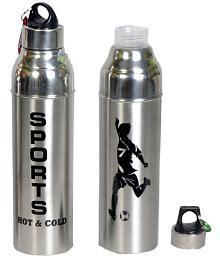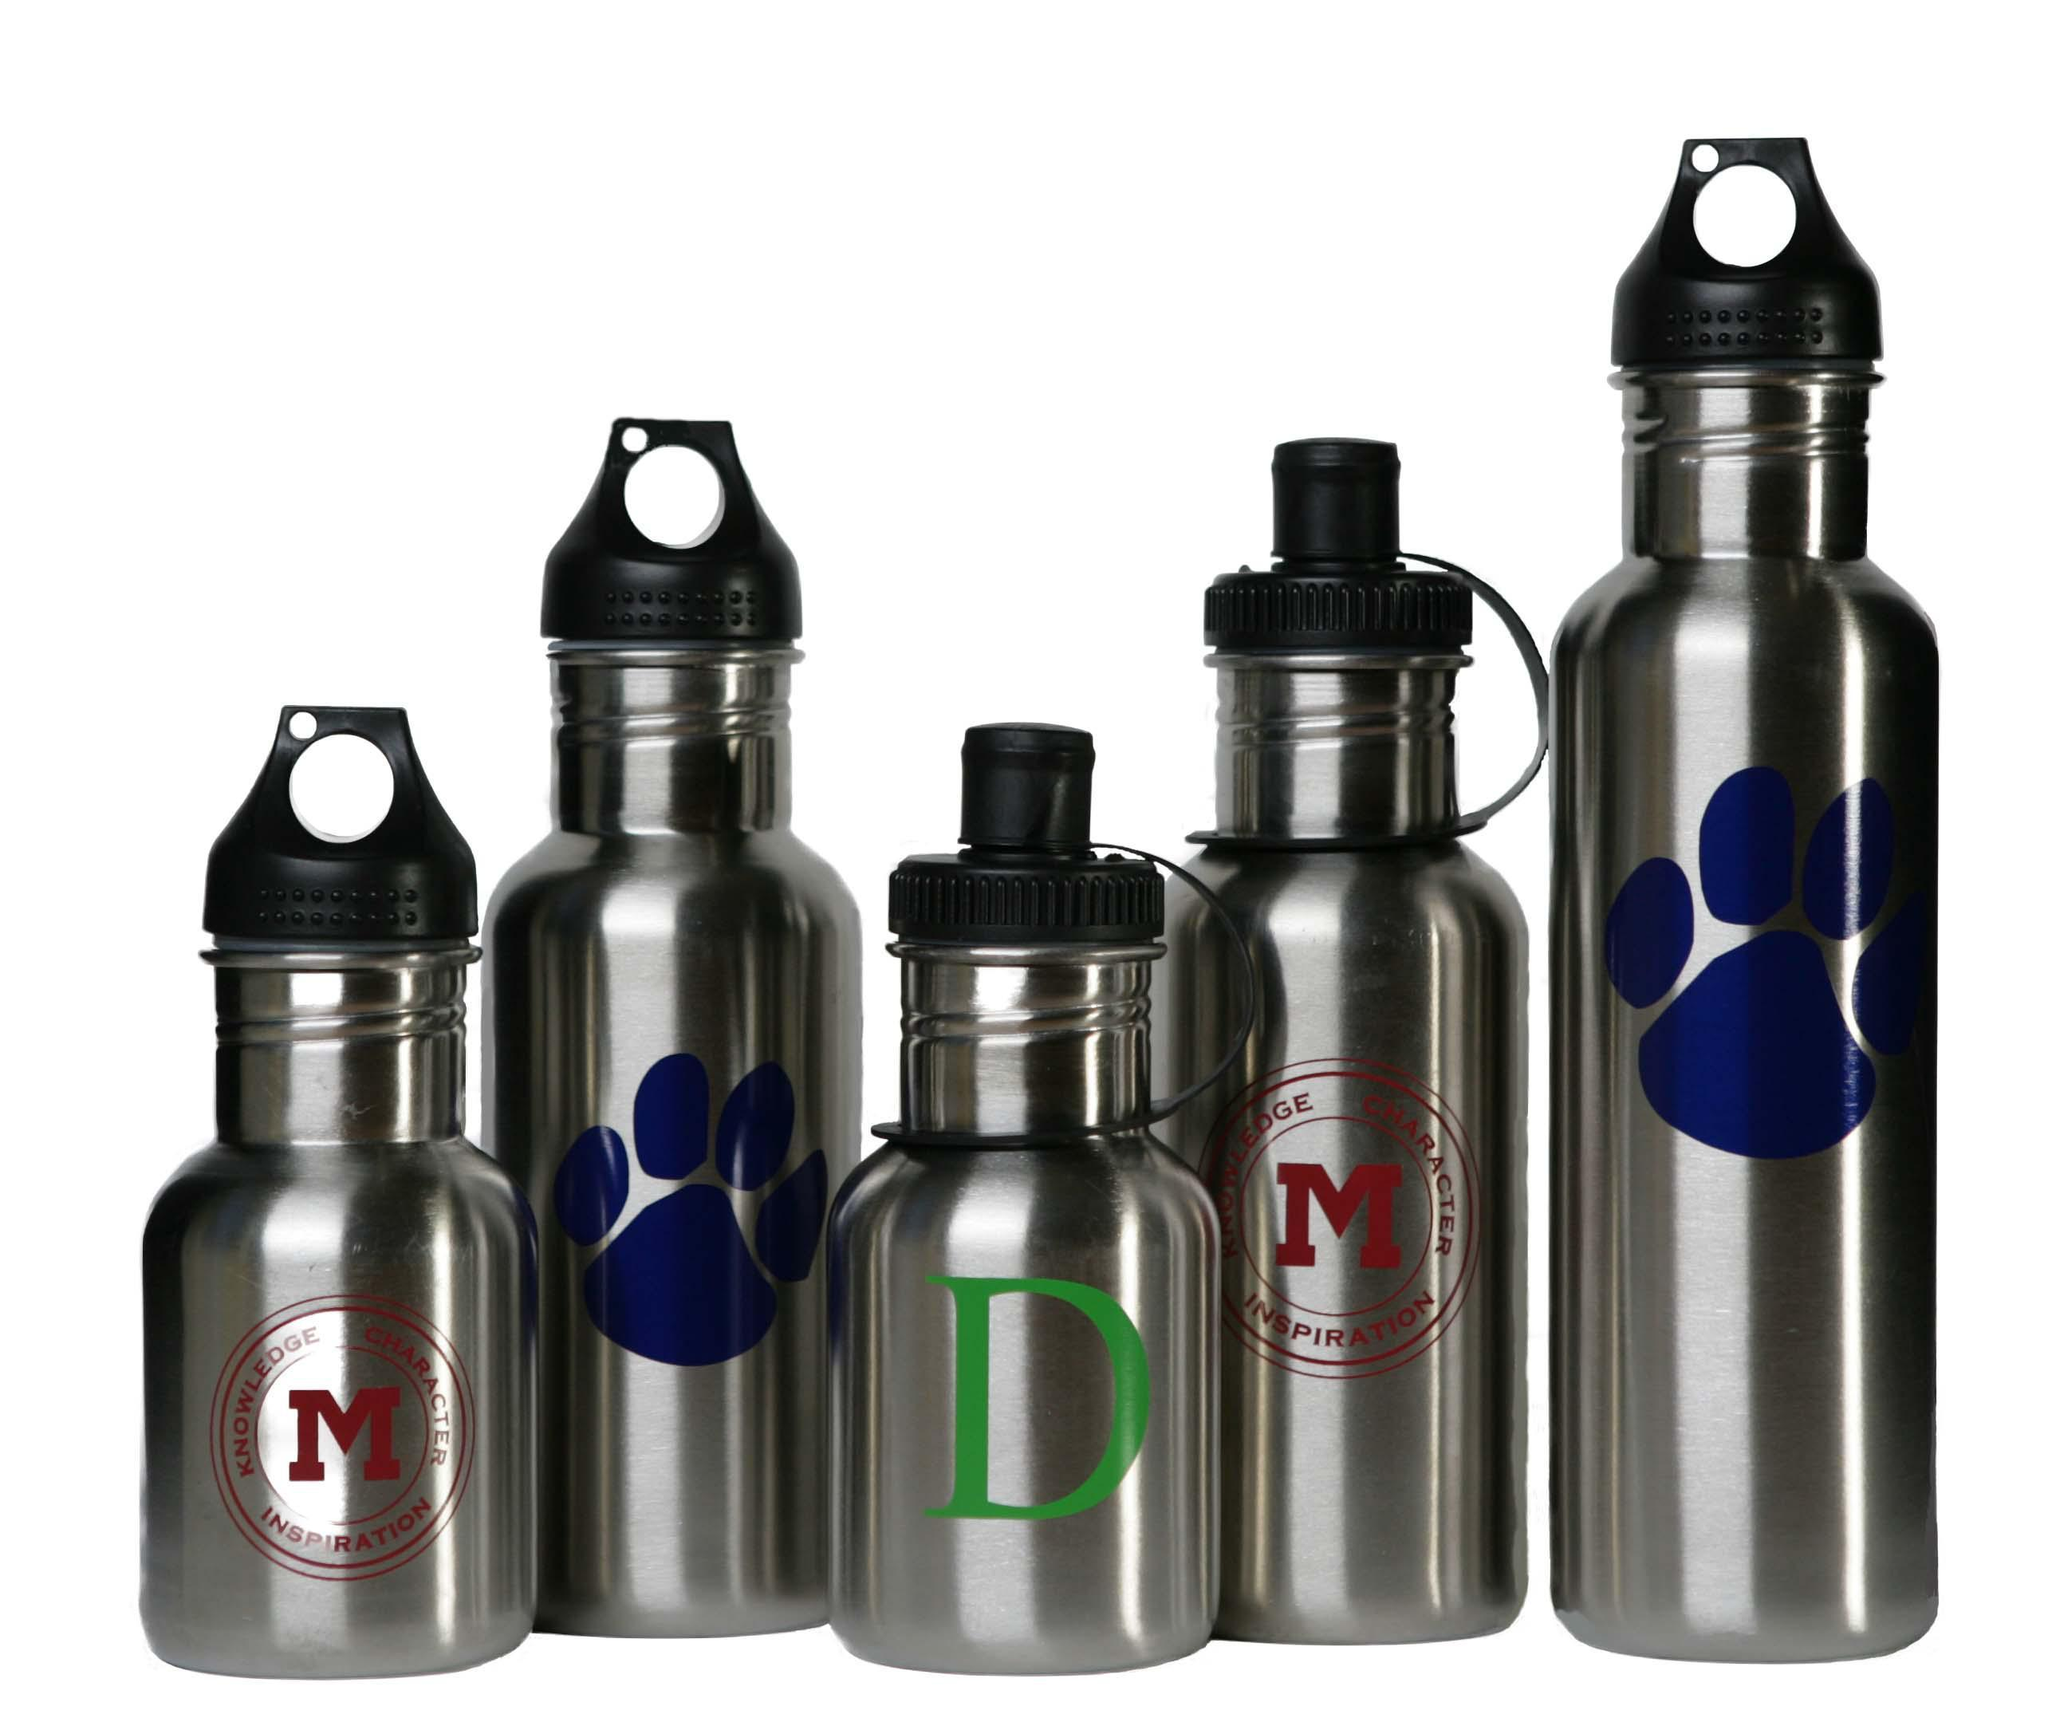The first image is the image on the left, the second image is the image on the right. For the images shown, is this caption "The left and right image contains the same number of bottles." true? Answer yes or no. No. The first image is the image on the left, the second image is the image on the right. Evaluate the accuracy of this statement regarding the images: "The left image include blue, lavender and purple water bottles, and the right image includes silver, red and blue bottles, as well as three 'loops' on bottles.". Is it true? Answer yes or no. No. 